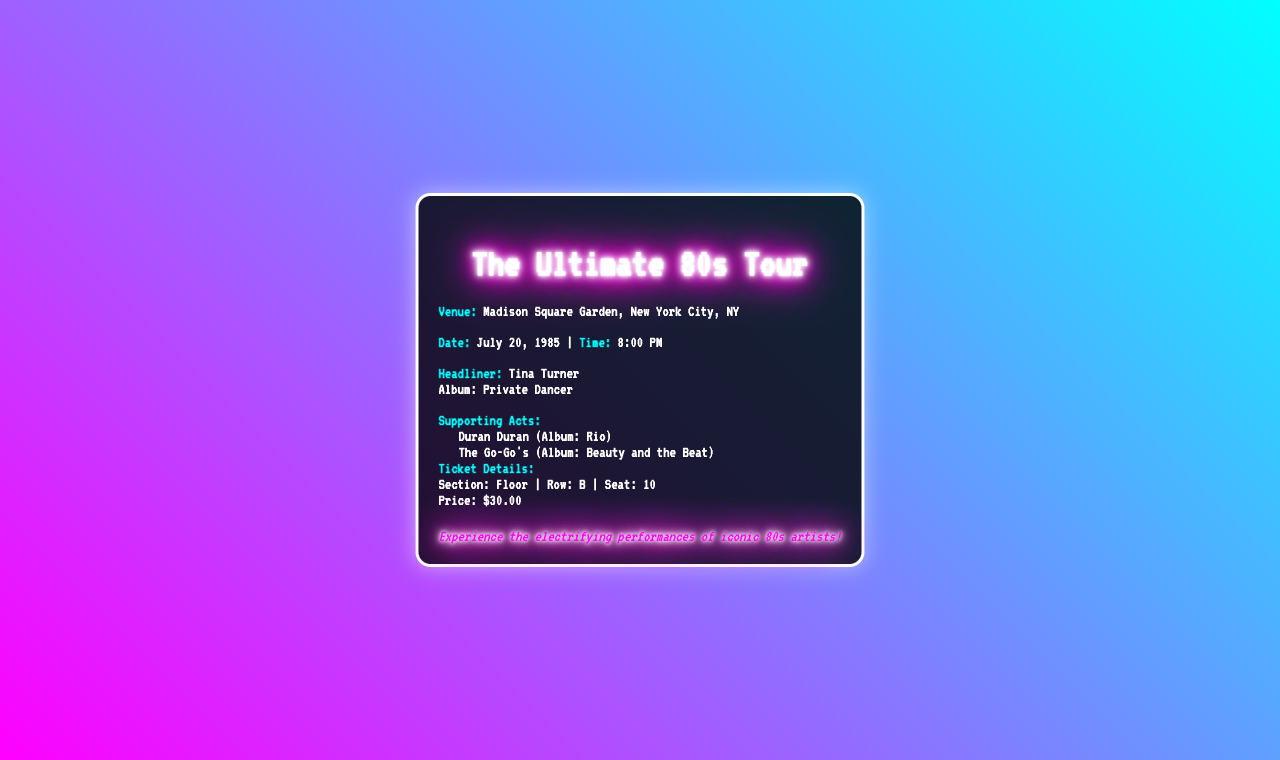what is the venue name? The venue name is mentioned in the ticket stub.
Answer: Madison Square Garden what is the date of the concert? The date is provided in the document.
Answer: July 20, 1985 who is the headliner of the concert? The headliner is specified in the document.
Answer: Tina Turner which album is associated with the headliner? The album is mentioned alongside the headliner.
Answer: Private Dancer who are the supporting acts? The supporting acts are listed under a specific section.
Answer: Duran Duran, The Go-Go's what is the price of the ticket? The price is indicated in the ticket details.
Answer: $30.00 what seat is assigned on the ticket? The seat information is provided in the ticket details section.
Answer: Seat: 10 what time does the concert start? The concert start time is included in the date information.
Answer: 8:00 PM how do the supporting acts relate to the headliner? The supporting acts are associated with the same concert event, enhancing its appeal.
Answer: They add variety to the concert experience 